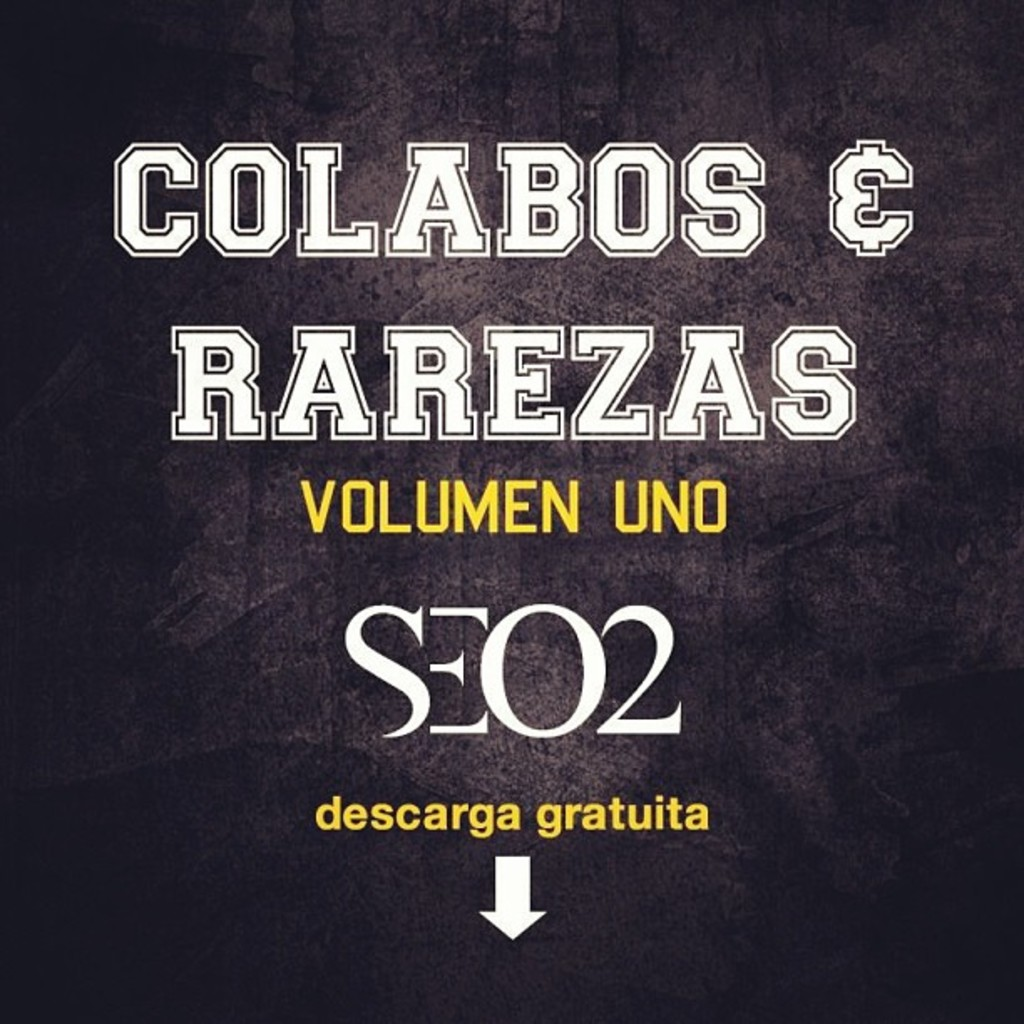Why would an artist choose to release an album for free? Releasing an album for free can be a strategic move by an artist. It can help to build a fanbase by making the music widely accessible, serve as a marketing tool to bring attention to their other paid content, or even as a thank you to loyal fans. For emerging artists, it's a way to get their music out into the world with minimal barriers for listeners, while established artists might do this to give back to their community or test out new musical directions. 